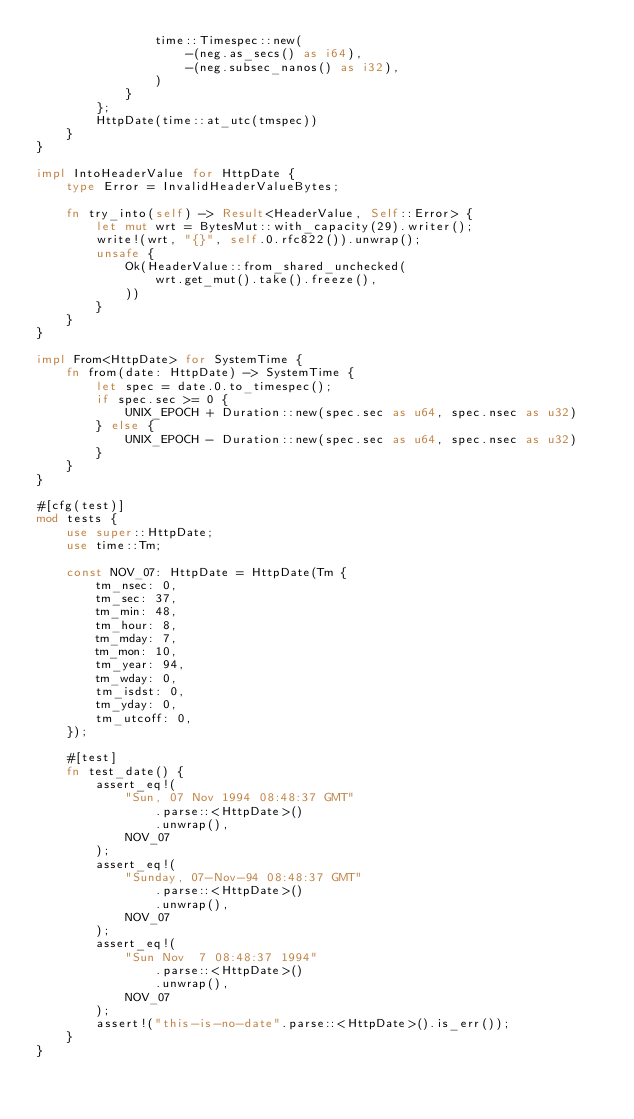<code> <loc_0><loc_0><loc_500><loc_500><_Rust_>                time::Timespec::new(
                    -(neg.as_secs() as i64),
                    -(neg.subsec_nanos() as i32),
                )
            }
        };
        HttpDate(time::at_utc(tmspec))
    }
}

impl IntoHeaderValue for HttpDate {
    type Error = InvalidHeaderValueBytes;

    fn try_into(self) -> Result<HeaderValue, Self::Error> {
        let mut wrt = BytesMut::with_capacity(29).writer();
        write!(wrt, "{}", self.0.rfc822()).unwrap();
        unsafe {
            Ok(HeaderValue::from_shared_unchecked(
                wrt.get_mut().take().freeze(),
            ))
        }
    }
}

impl From<HttpDate> for SystemTime {
    fn from(date: HttpDate) -> SystemTime {
        let spec = date.0.to_timespec();
        if spec.sec >= 0 {
            UNIX_EPOCH + Duration::new(spec.sec as u64, spec.nsec as u32)
        } else {
            UNIX_EPOCH - Duration::new(spec.sec as u64, spec.nsec as u32)
        }
    }
}

#[cfg(test)]
mod tests {
    use super::HttpDate;
    use time::Tm;

    const NOV_07: HttpDate = HttpDate(Tm {
        tm_nsec: 0,
        tm_sec: 37,
        tm_min: 48,
        tm_hour: 8,
        tm_mday: 7,
        tm_mon: 10,
        tm_year: 94,
        tm_wday: 0,
        tm_isdst: 0,
        tm_yday: 0,
        tm_utcoff: 0,
    });

    #[test]
    fn test_date() {
        assert_eq!(
            "Sun, 07 Nov 1994 08:48:37 GMT"
                .parse::<HttpDate>()
                .unwrap(),
            NOV_07
        );
        assert_eq!(
            "Sunday, 07-Nov-94 08:48:37 GMT"
                .parse::<HttpDate>()
                .unwrap(),
            NOV_07
        );
        assert_eq!(
            "Sun Nov  7 08:48:37 1994"
                .parse::<HttpDate>()
                .unwrap(),
            NOV_07
        );
        assert!("this-is-no-date".parse::<HttpDate>().is_err());
    }
}
</code> 